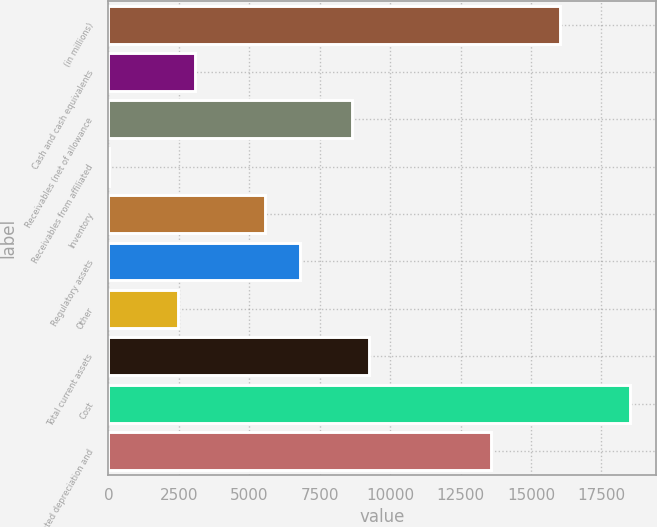Convert chart. <chart><loc_0><loc_0><loc_500><loc_500><bar_chart><fcel>(in millions)<fcel>Cash and cash equivalents<fcel>Receivables (net of allowance<fcel>Receivables from affiliated<fcel>Inventory<fcel>Regulatory assets<fcel>Other<fcel>Total current assets<fcel>Cost<fcel>Accumulated depreciation and<nl><fcel>16041.2<fcel>3090.5<fcel>8640.8<fcel>7<fcel>5557.3<fcel>6790.7<fcel>2473.8<fcel>9257.5<fcel>18508<fcel>13574.4<nl></chart> 